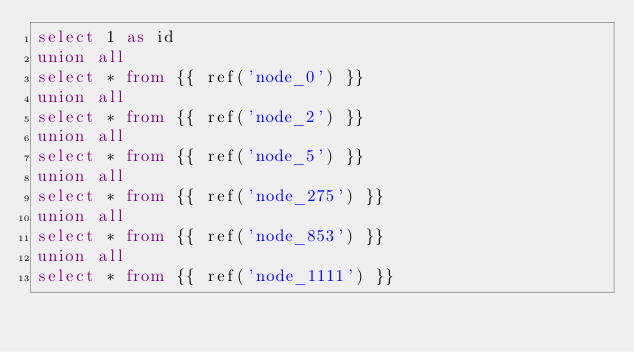Convert code to text. <code><loc_0><loc_0><loc_500><loc_500><_SQL_>select 1 as id
union all
select * from {{ ref('node_0') }}
union all
select * from {{ ref('node_2') }}
union all
select * from {{ ref('node_5') }}
union all
select * from {{ ref('node_275') }}
union all
select * from {{ ref('node_853') }}
union all
select * from {{ ref('node_1111') }}
</code> 